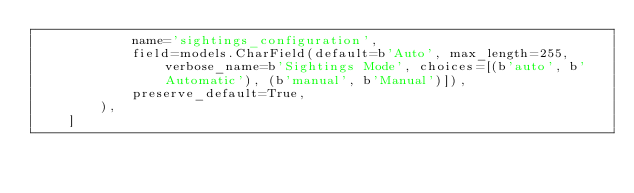Convert code to text. <code><loc_0><loc_0><loc_500><loc_500><_Python_>            name='sightings_configuration',
            field=models.CharField(default=b'Auto', max_length=255, verbose_name=b'Sightings Mode', choices=[(b'auto', b'Automatic'), (b'manual', b'Manual')]),
            preserve_default=True,
        ),
    ]
</code> 